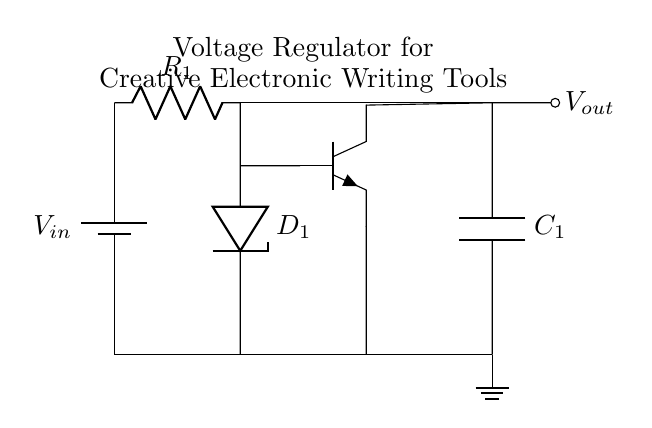What type of diode is used in this circuit? The circuit uses a Zener diode, which is specifically indicated by the label D_1. This type of diode is used for voltage regulation due to its ability to maintain a constant output voltage when reverse biased.
Answer: Zener What is the role of the resistor in this circuit? The resistor R_1 limits the current flowing through the Zener diode and the transistor, protecting them from excessive current that could cause damage. It also helps to stabilize the voltage output by creating a voltage drop across it.
Answer: Current limiter How many main components are present in the circuit? The circuit consists of six main components: one Zener diode, one resistor, one transistor, one capacitor, one battery, and one ground connection. Counting each type gives a total of six distinct components.
Answer: Six What is the purpose of the output capacitor? The output capacitor C_1 smooths the output voltage, reducing voltage ripples and providing a stable power supply to connected devices. This stabilization is crucial for maintaining consistent performance in sensitive electronic writing tools.
Answer: Smoothing voltage Where is the output voltage taken from in the circuit? The output voltage, referred to as V_out, is taken from the node connected to the output capacitor C_1, which stabilizes and filters the voltage before it is supplied to the load.
Answer: From the capacitor What type of transistor is used in this circuit? The circuit includes an NPN transistor, indicated by the notation "npn" in the circuit diagram. NPN transistors are commonly used in voltage regulation circuits due to their capability to amplify current and provide stable output.
Answer: NPN What is the input voltage labeled in the circuit? The input voltage is labeled as V_in, which is connected to the positive terminal of the battery. This input is the voltage supplied to the circuit and is crucial for the operation of the voltage regulator.
Answer: V_in 